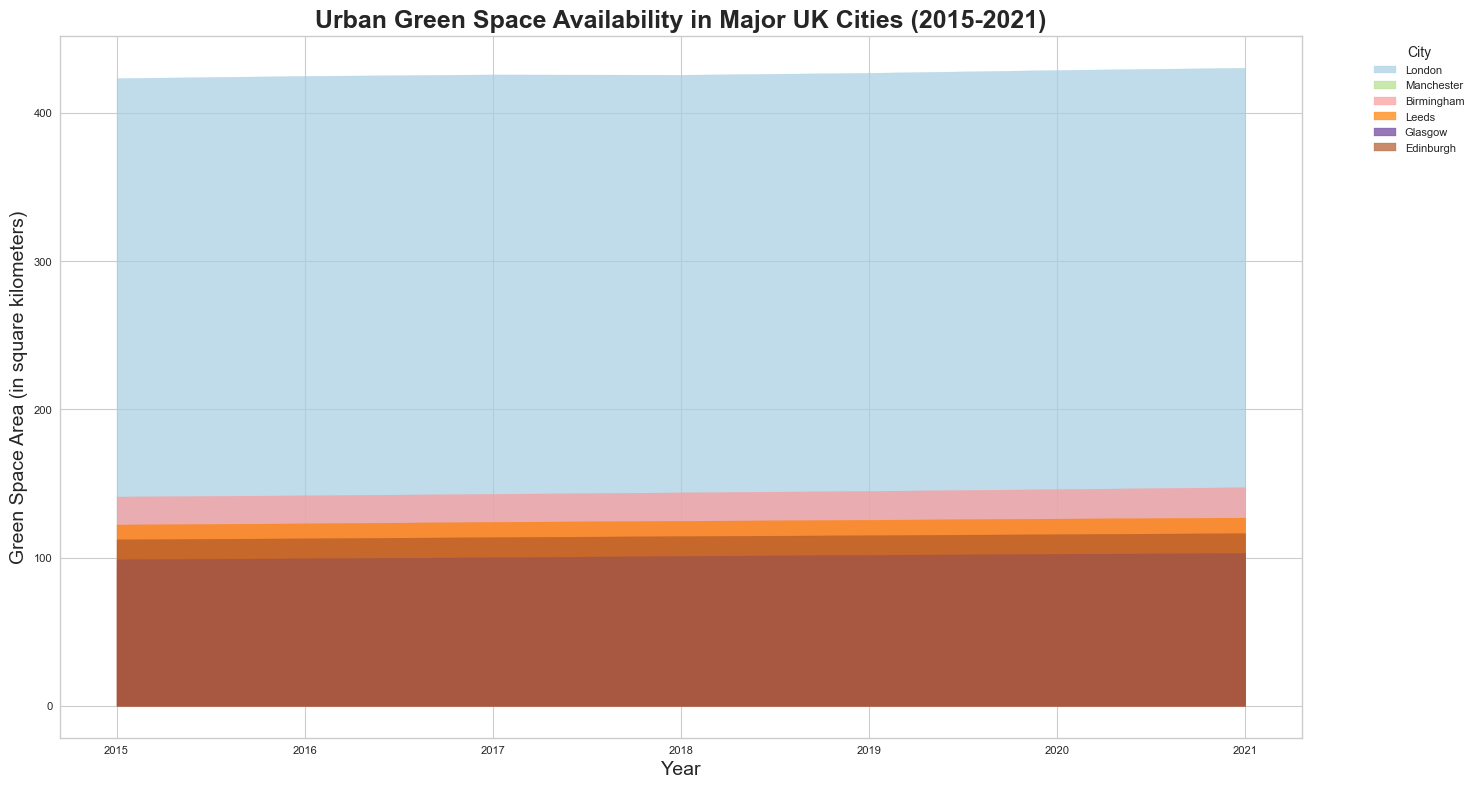What is the trend of green space area in London from 2015 to 2021? The chart shows green space area for London each year from 2015 to 2021. Observing the filled area for London, it generally increases from 2015 (423.5) to 2021 (430.5), indicating an upward trend.
Answer: Upward trend Which city had the largest green space area in 2021? Comparing the heights of the filled areas in 2021, London has the highest level of green space area followed by Birmingham, Leeds, Edinburgh, Glasgow, and Manchester. London has the largest area at 430.5 square kilometers.
Answer: London Which two cities had the closest green space areas in 2021? In 2021, comparing the filled areas' heights for each city, Glasgow (103.1) and Edinburgh (116.5) have the closest areas, with a difference of 13.4 square kilometers.
Answer: Glasgow and Edinburgh By how much did the green space area in Manchester increase from 2015 to 2021? The green space area in Manchester in 2015 was 92.3 sq km and in 2021 it was 96.2 sq km. The increase is calculated by 96.2 - 92.3 = 3.9 sq km.
Answer: 3.9 sq km Which city shows the least change in green space area from 2015 to 2021? Observing the filled area heights for each city between 2015 and 2021, London’s green space area changes minimally, displaying the least variation compared to other cities.
Answer: London How does the trend of green space area in Birmingham compare to Leeds from 2015 to 2021? Both Birmingham and Leeds show an increasing trend in green space area from 2015 to 2021. Birmingham’s area increases from 141.2 to 147.5 sq km, while Leeds’ rises from 122.3 to 127.0 sq km. Both cities show consistent growth over the years.
Answer: Increasing trend in both cities What is the difference in green space area between Glasgow and Edinburgh in 2018? In 2018, Glasgow has 101.1 sq km of green space and Edinburgh has 114.5 sq km. The difference is 114.5 - 101.1 = 13.4 sq km.
Answer: 13.4 sq km Which city had the smallest green space area in 2015 and how much was it? Observing the filled areas for 2015, Manchester had the smallest green space area with 92.3 square kilometers.
Answer: Manchester, 92.3 sq km What is the overall average green space area across all cities in 2020? Adding the green space areas for all cities in 2020: London (429) + Manchester (95.6) + Birmingham (146.2) + Leeds (126.3) + Glasgow (102.5) + Edinburgh (115.8) = 1015.4 square kilometers. Dividing by 6 cities, the average is 1015.4 / 6 ≈ 169.23 sq km.
Answer: Approx. 169.23 sq km 